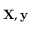Convert formula to latex. <formula><loc_0><loc_0><loc_500><loc_500>X , y</formula> 